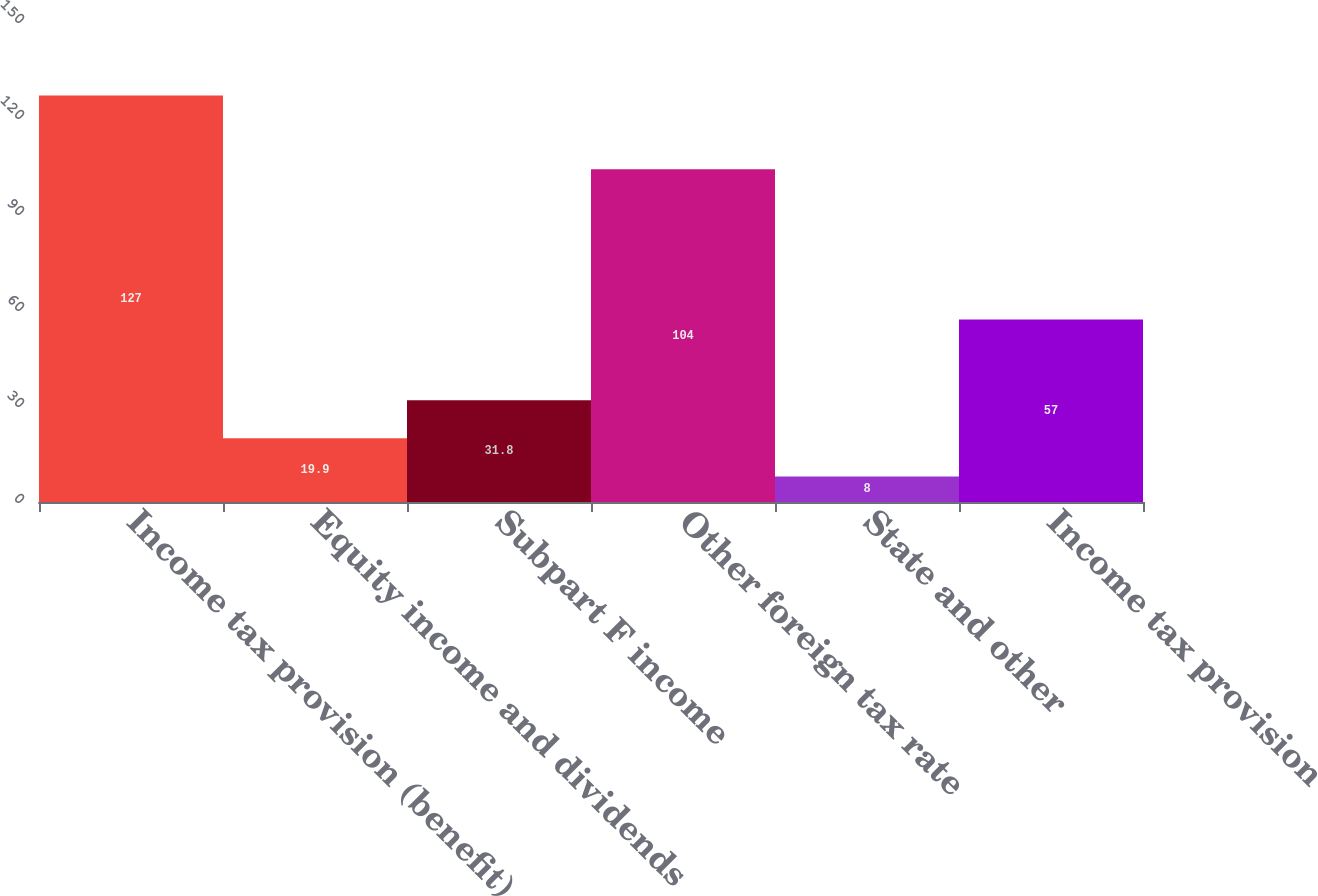Convert chart. <chart><loc_0><loc_0><loc_500><loc_500><bar_chart><fcel>Income tax provision (benefit)<fcel>Equity income and dividends<fcel>Subpart F income<fcel>Other foreign tax rate<fcel>State and other<fcel>Income tax provision<nl><fcel>127<fcel>19.9<fcel>31.8<fcel>104<fcel>8<fcel>57<nl></chart> 